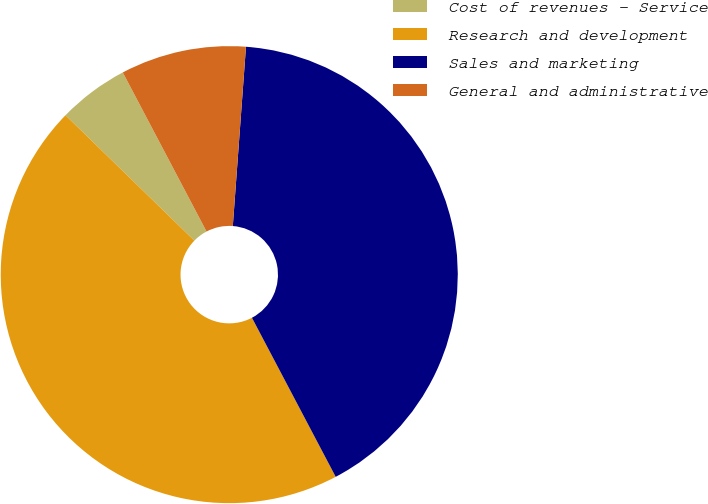Convert chart to OTSL. <chart><loc_0><loc_0><loc_500><loc_500><pie_chart><fcel>Cost of revenues - Service<fcel>Research and development<fcel>Sales and marketing<fcel>General and administrative<nl><fcel>5.0%<fcel>45.0%<fcel>41.12%<fcel>8.88%<nl></chart> 